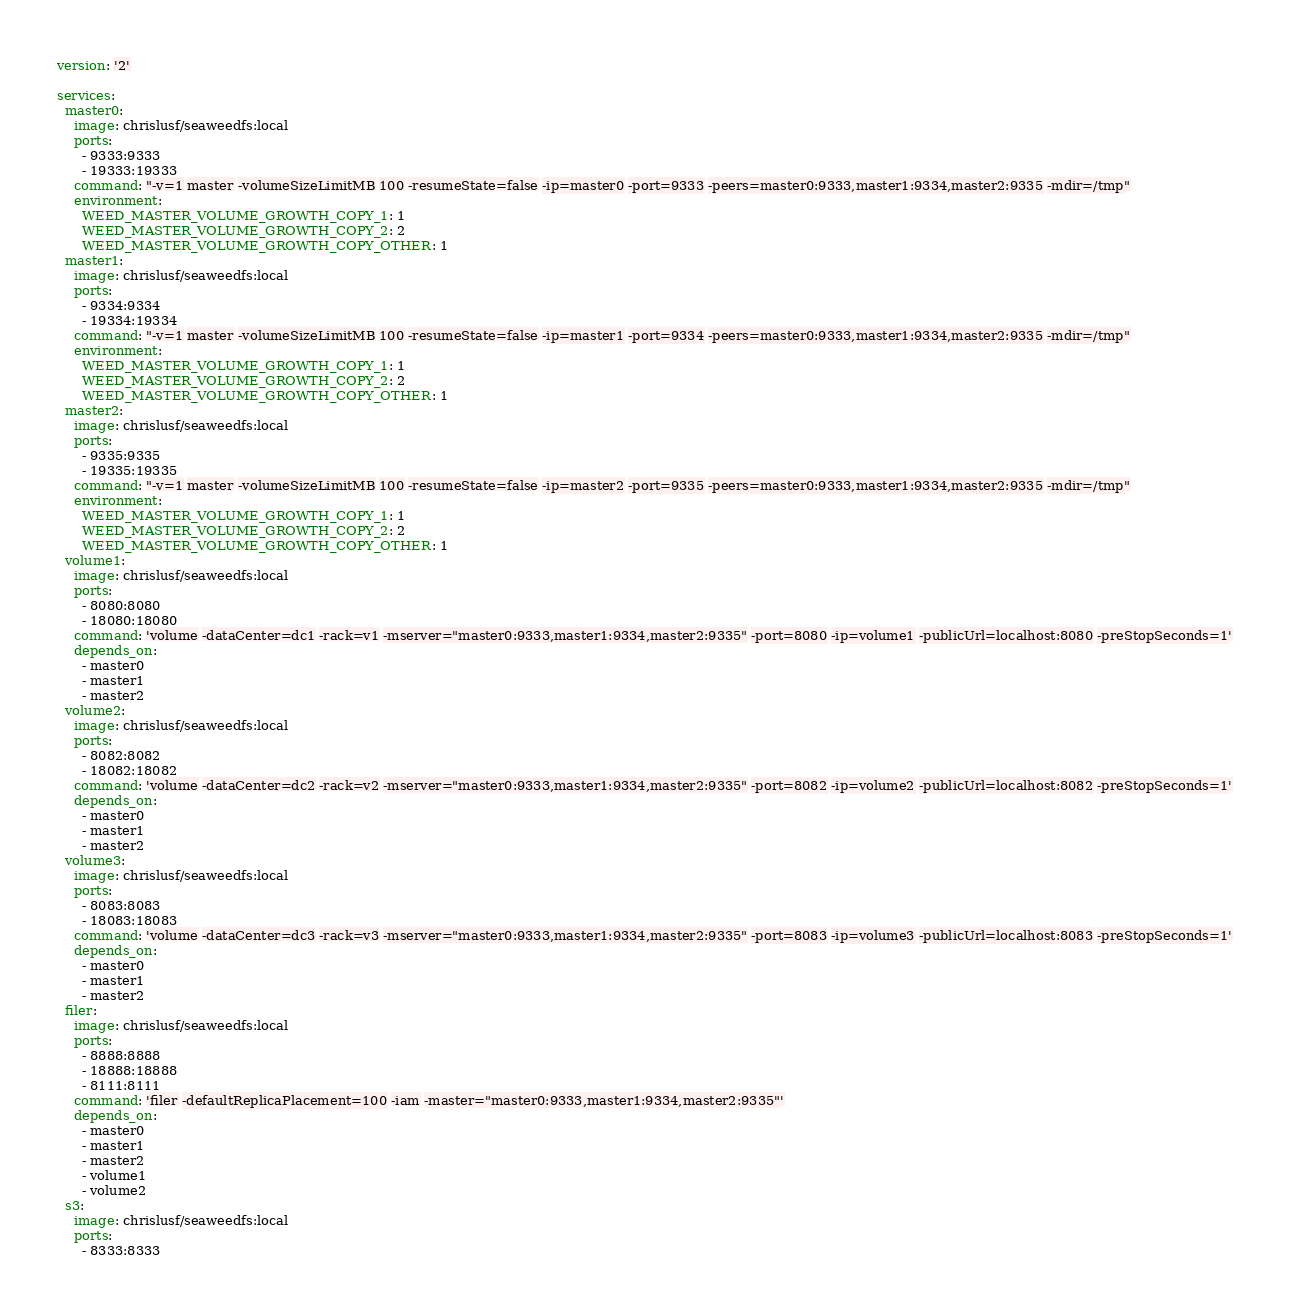Convert code to text. <code><loc_0><loc_0><loc_500><loc_500><_YAML_>version: '2'

services:
  master0:
    image: chrislusf/seaweedfs:local
    ports:
      - 9333:9333
      - 19333:19333
    command: "-v=1 master -volumeSizeLimitMB 100 -resumeState=false -ip=master0 -port=9333 -peers=master0:9333,master1:9334,master2:9335 -mdir=/tmp"
    environment:
      WEED_MASTER_VOLUME_GROWTH_COPY_1: 1
      WEED_MASTER_VOLUME_GROWTH_COPY_2: 2
      WEED_MASTER_VOLUME_GROWTH_COPY_OTHER: 1
  master1:
    image: chrislusf/seaweedfs:local
    ports:
      - 9334:9334
      - 19334:19334
    command: "-v=1 master -volumeSizeLimitMB 100 -resumeState=false -ip=master1 -port=9334 -peers=master0:9333,master1:9334,master2:9335 -mdir=/tmp"
    environment:
      WEED_MASTER_VOLUME_GROWTH_COPY_1: 1
      WEED_MASTER_VOLUME_GROWTH_COPY_2: 2
      WEED_MASTER_VOLUME_GROWTH_COPY_OTHER: 1
  master2:
    image: chrislusf/seaweedfs:local
    ports:
      - 9335:9335
      - 19335:19335
    command: "-v=1 master -volumeSizeLimitMB 100 -resumeState=false -ip=master2 -port=9335 -peers=master0:9333,master1:9334,master2:9335 -mdir=/tmp"
    environment:
      WEED_MASTER_VOLUME_GROWTH_COPY_1: 1
      WEED_MASTER_VOLUME_GROWTH_COPY_2: 2
      WEED_MASTER_VOLUME_GROWTH_COPY_OTHER: 1
  volume1:
    image: chrislusf/seaweedfs:local
    ports:
      - 8080:8080
      - 18080:18080
    command: 'volume -dataCenter=dc1 -rack=v1 -mserver="master0:9333,master1:9334,master2:9335" -port=8080 -ip=volume1 -publicUrl=localhost:8080 -preStopSeconds=1'
    depends_on:
      - master0
      - master1
      - master2
  volume2:
    image: chrislusf/seaweedfs:local
    ports:
      - 8082:8082
      - 18082:18082
    command: 'volume -dataCenter=dc2 -rack=v2 -mserver="master0:9333,master1:9334,master2:9335" -port=8082 -ip=volume2 -publicUrl=localhost:8082 -preStopSeconds=1'
    depends_on:
      - master0
      - master1
      - master2
  volume3:
    image: chrislusf/seaweedfs:local
    ports:
      - 8083:8083
      - 18083:18083
    command: 'volume -dataCenter=dc3 -rack=v3 -mserver="master0:9333,master1:9334,master2:9335" -port=8083 -ip=volume3 -publicUrl=localhost:8083 -preStopSeconds=1'
    depends_on:
      - master0
      - master1
      - master2
  filer:
    image: chrislusf/seaweedfs:local
    ports:
      - 8888:8888
      - 18888:18888
      - 8111:8111
    command: 'filer -defaultReplicaPlacement=100 -iam -master="master0:9333,master1:9334,master2:9335"'
    depends_on:
      - master0
      - master1
      - master2
      - volume1
      - volume2
  s3:
    image: chrislusf/seaweedfs:local
    ports:
      - 8333:8333</code> 